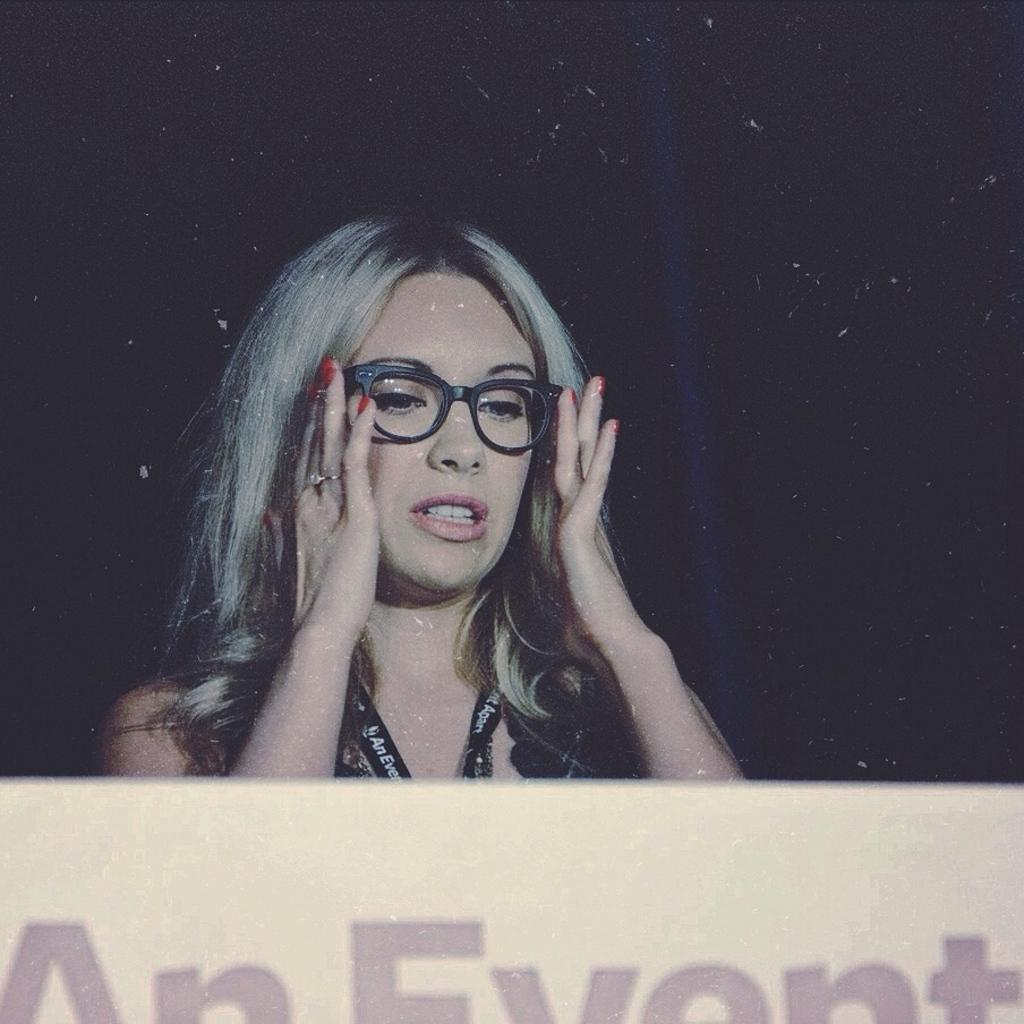Who or what is the main subject in the image? There is a person in the image. What is the person wearing? The person is wearing a black dress. What object can be seen in the image besides the person? There is a white board in the image. How would you describe the overall lighting or color of the background in the image? The background of the image is dark. How much does the pencil weigh in the image? There is no pencil present in the image, so it is not possible to determine its weight. 